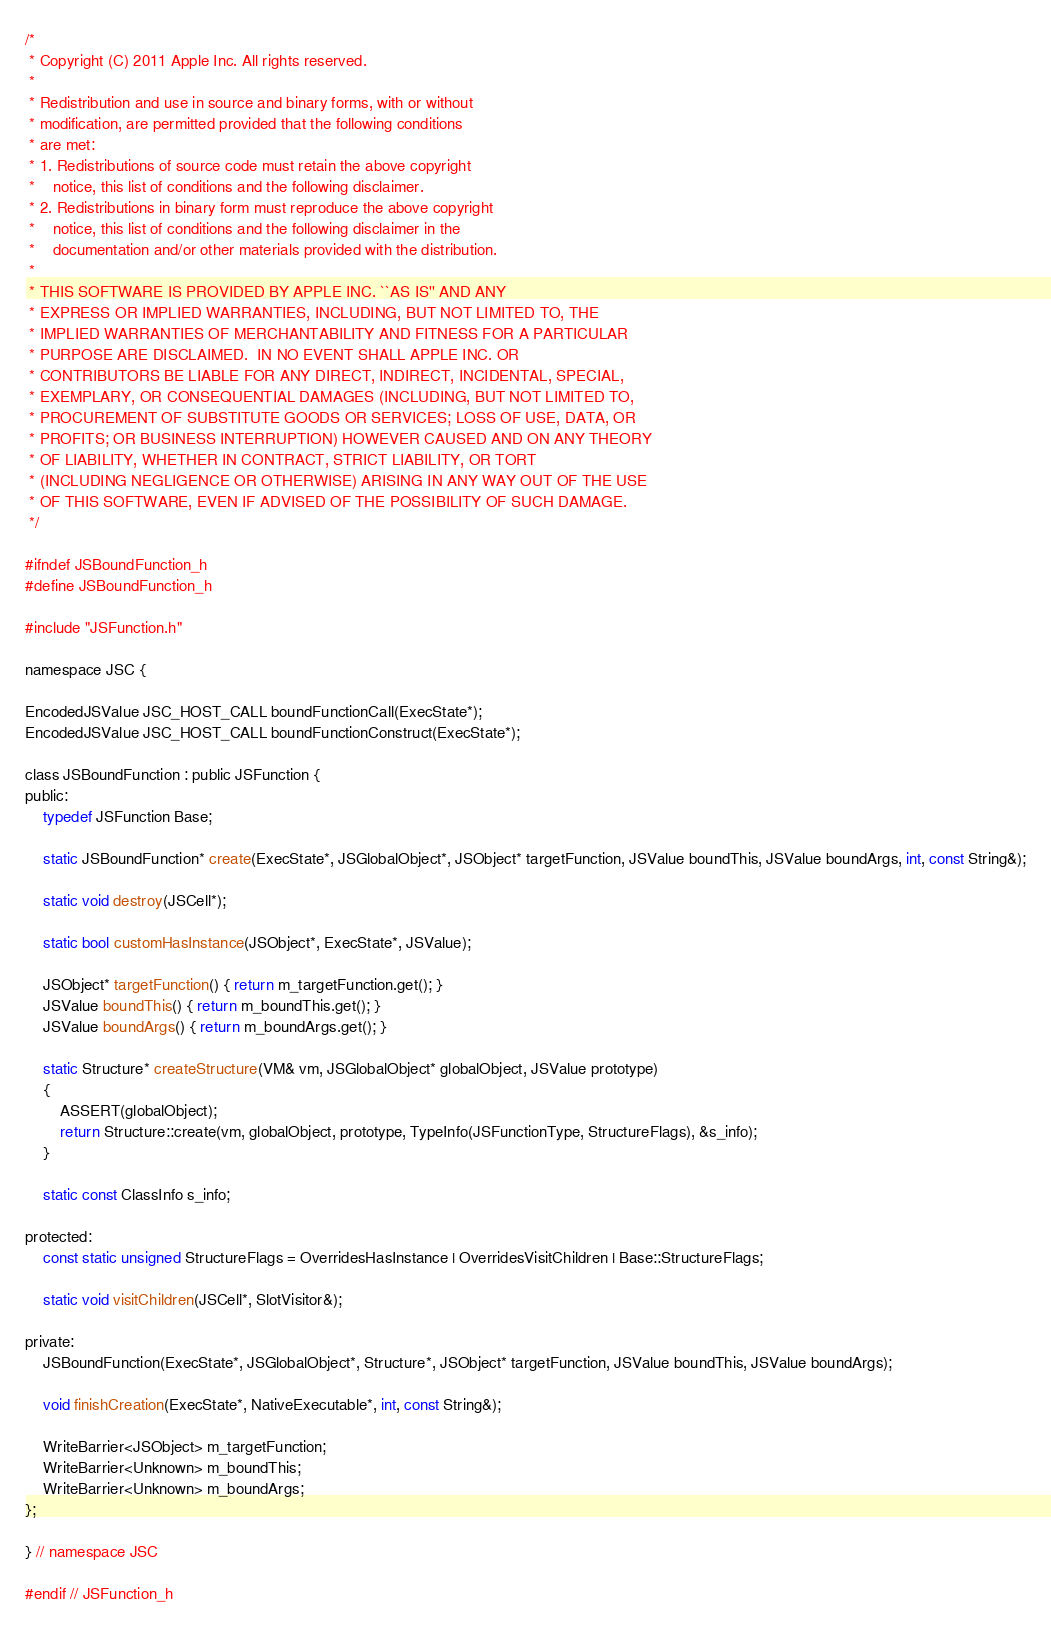<code> <loc_0><loc_0><loc_500><loc_500><_C_>/*
 * Copyright (C) 2011 Apple Inc. All rights reserved.
 *
 * Redistribution and use in source and binary forms, with or without
 * modification, are permitted provided that the following conditions
 * are met:
 * 1. Redistributions of source code must retain the above copyright
 *    notice, this list of conditions and the following disclaimer.
 * 2. Redistributions in binary form must reproduce the above copyright
 *    notice, this list of conditions and the following disclaimer in the
 *    documentation and/or other materials provided with the distribution.
 *
 * THIS SOFTWARE IS PROVIDED BY APPLE INC. ``AS IS'' AND ANY
 * EXPRESS OR IMPLIED WARRANTIES, INCLUDING, BUT NOT LIMITED TO, THE
 * IMPLIED WARRANTIES OF MERCHANTABILITY AND FITNESS FOR A PARTICULAR
 * PURPOSE ARE DISCLAIMED.  IN NO EVENT SHALL APPLE INC. OR
 * CONTRIBUTORS BE LIABLE FOR ANY DIRECT, INDIRECT, INCIDENTAL, SPECIAL,
 * EXEMPLARY, OR CONSEQUENTIAL DAMAGES (INCLUDING, BUT NOT LIMITED TO,
 * PROCUREMENT OF SUBSTITUTE GOODS OR SERVICES; LOSS OF USE, DATA, OR
 * PROFITS; OR BUSINESS INTERRUPTION) HOWEVER CAUSED AND ON ANY THEORY
 * OF LIABILITY, WHETHER IN CONTRACT, STRICT LIABILITY, OR TORT
 * (INCLUDING NEGLIGENCE OR OTHERWISE) ARISING IN ANY WAY OUT OF THE USE
 * OF THIS SOFTWARE, EVEN IF ADVISED OF THE POSSIBILITY OF SUCH DAMAGE. 
 */

#ifndef JSBoundFunction_h
#define JSBoundFunction_h

#include "JSFunction.h"

namespace JSC {

EncodedJSValue JSC_HOST_CALL boundFunctionCall(ExecState*);
EncodedJSValue JSC_HOST_CALL boundFunctionConstruct(ExecState*);

class JSBoundFunction : public JSFunction {
public:
    typedef JSFunction Base;

    static JSBoundFunction* create(ExecState*, JSGlobalObject*, JSObject* targetFunction, JSValue boundThis, JSValue boundArgs, int, const String&);
    
    static void destroy(JSCell*);

    static bool customHasInstance(JSObject*, ExecState*, JSValue);

    JSObject* targetFunction() { return m_targetFunction.get(); }
    JSValue boundThis() { return m_boundThis.get(); }
    JSValue boundArgs() { return m_boundArgs.get(); }

    static Structure* createStructure(VM& vm, JSGlobalObject* globalObject, JSValue prototype) 
    {
        ASSERT(globalObject);
        return Structure::create(vm, globalObject, prototype, TypeInfo(JSFunctionType, StructureFlags), &s_info); 
    }

    static const ClassInfo s_info;

protected:
    const static unsigned StructureFlags = OverridesHasInstance | OverridesVisitChildren | Base::StructureFlags;

    static void visitChildren(JSCell*, SlotVisitor&);

private:
    JSBoundFunction(ExecState*, JSGlobalObject*, Structure*, JSObject* targetFunction, JSValue boundThis, JSValue boundArgs);
    
    void finishCreation(ExecState*, NativeExecutable*, int, const String&);

    WriteBarrier<JSObject> m_targetFunction;
    WriteBarrier<Unknown> m_boundThis;
    WriteBarrier<Unknown> m_boundArgs;
};

} // namespace JSC

#endif // JSFunction_h
</code> 